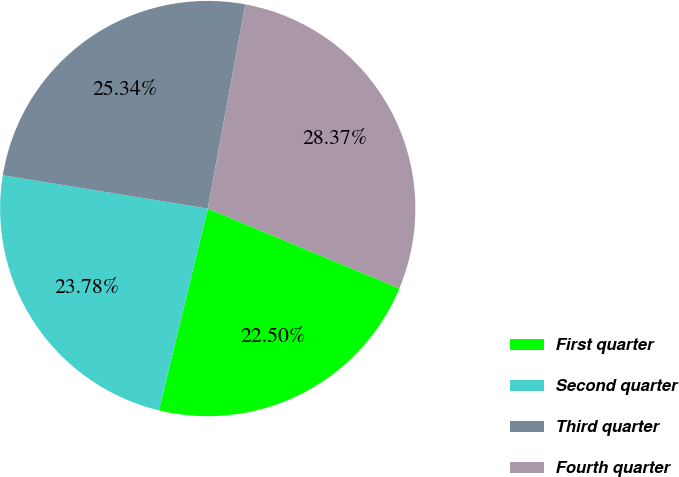<chart> <loc_0><loc_0><loc_500><loc_500><pie_chart><fcel>First quarter<fcel>Second quarter<fcel>Third quarter<fcel>Fourth quarter<nl><fcel>22.5%<fcel>23.78%<fcel>25.34%<fcel>28.37%<nl></chart> 